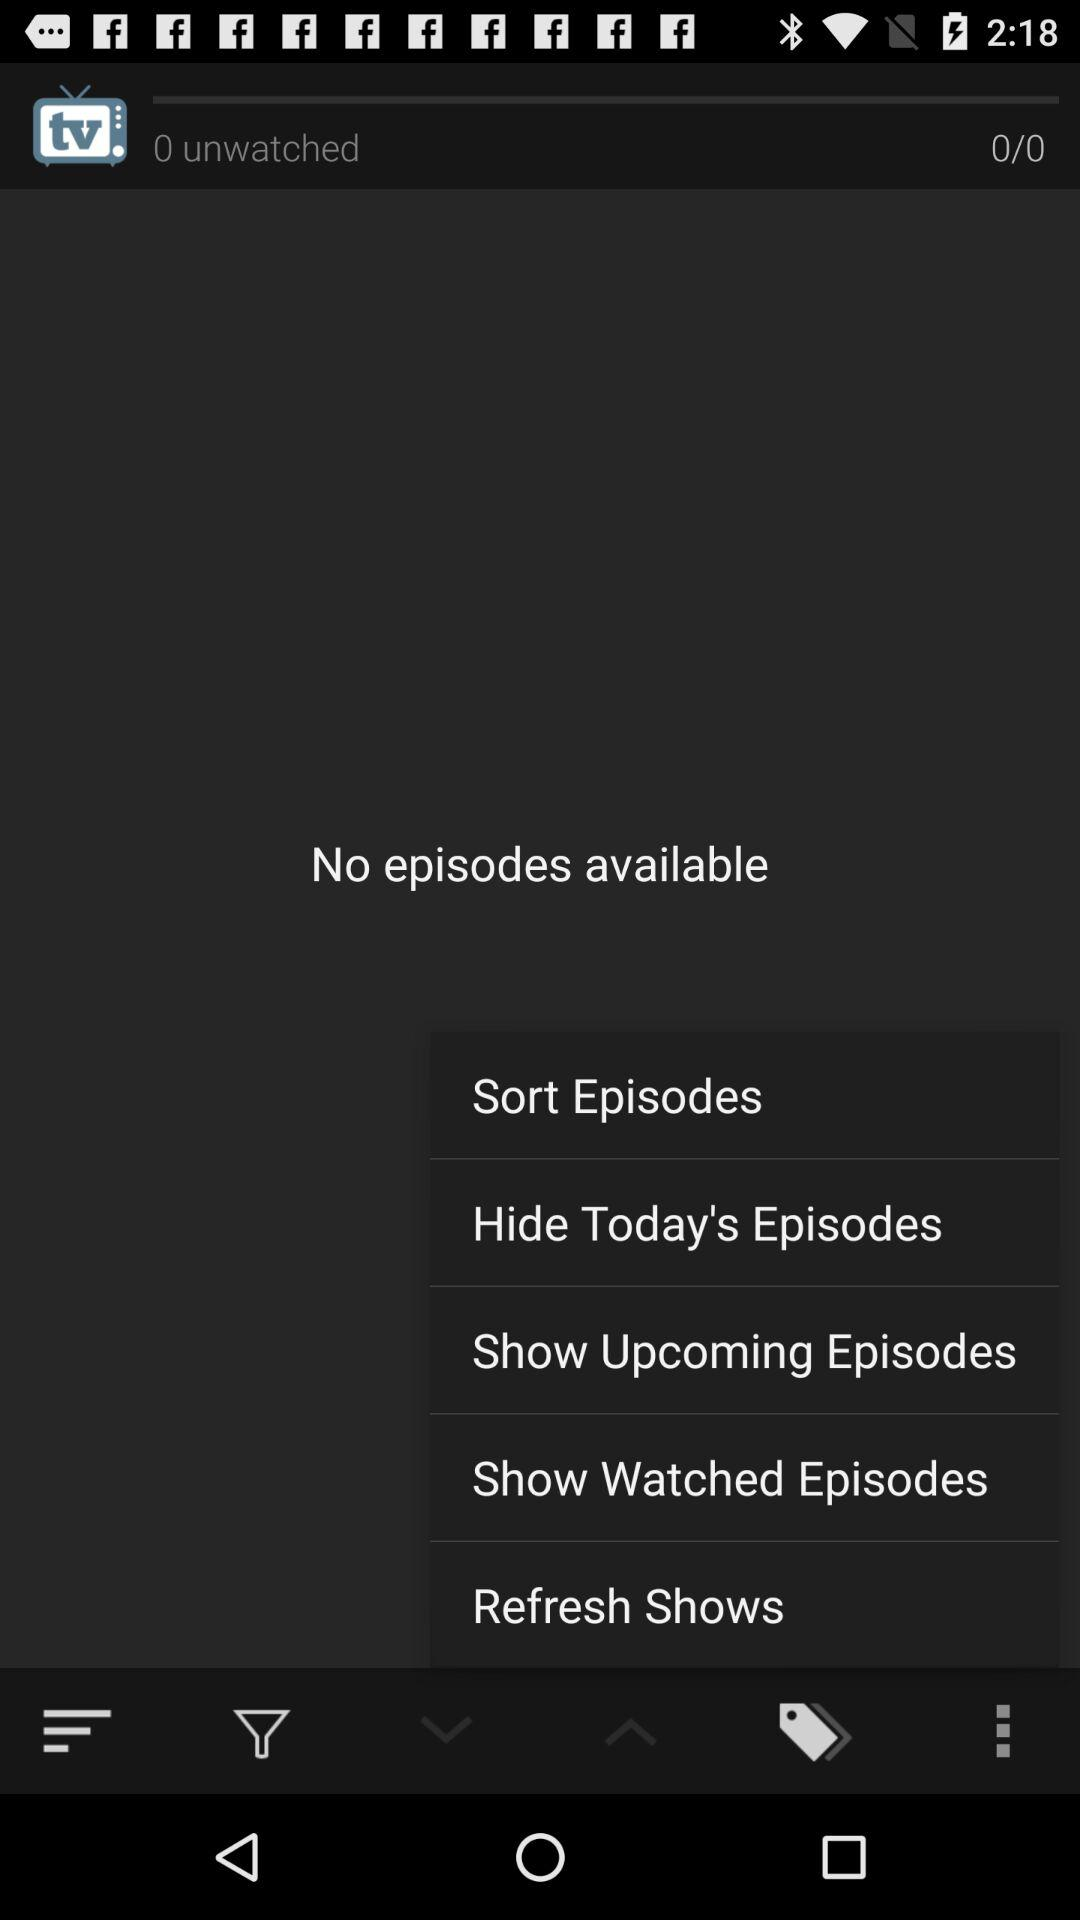How many episodes are available for this show?
Answer the question using a single word or phrase. 0 